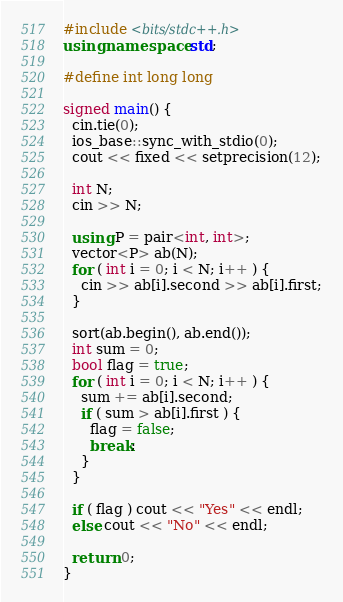<code> <loc_0><loc_0><loc_500><loc_500><_C++_>#include <bits/stdc++.h>
using namespace std;

#define int long long

signed main() {
  cin.tie(0);
  ios_base::sync_with_stdio(0);
  cout << fixed << setprecision(12);

  int N;
  cin >> N;

  using P = pair<int, int>;
  vector<P> ab(N);
  for ( int i = 0; i < N; i++ ) {
    cin >> ab[i].second >> ab[i].first;
  }

  sort(ab.begin(), ab.end());
  int sum = 0;
  bool flag = true;
  for ( int i = 0; i < N; i++ ) {
    sum += ab[i].second;
    if ( sum > ab[i].first ) {
      flag = false;
      break;
    }
  }

  if ( flag ) cout << "Yes" << endl;
  else cout << "No" << endl;
  
  return 0;
}
</code> 